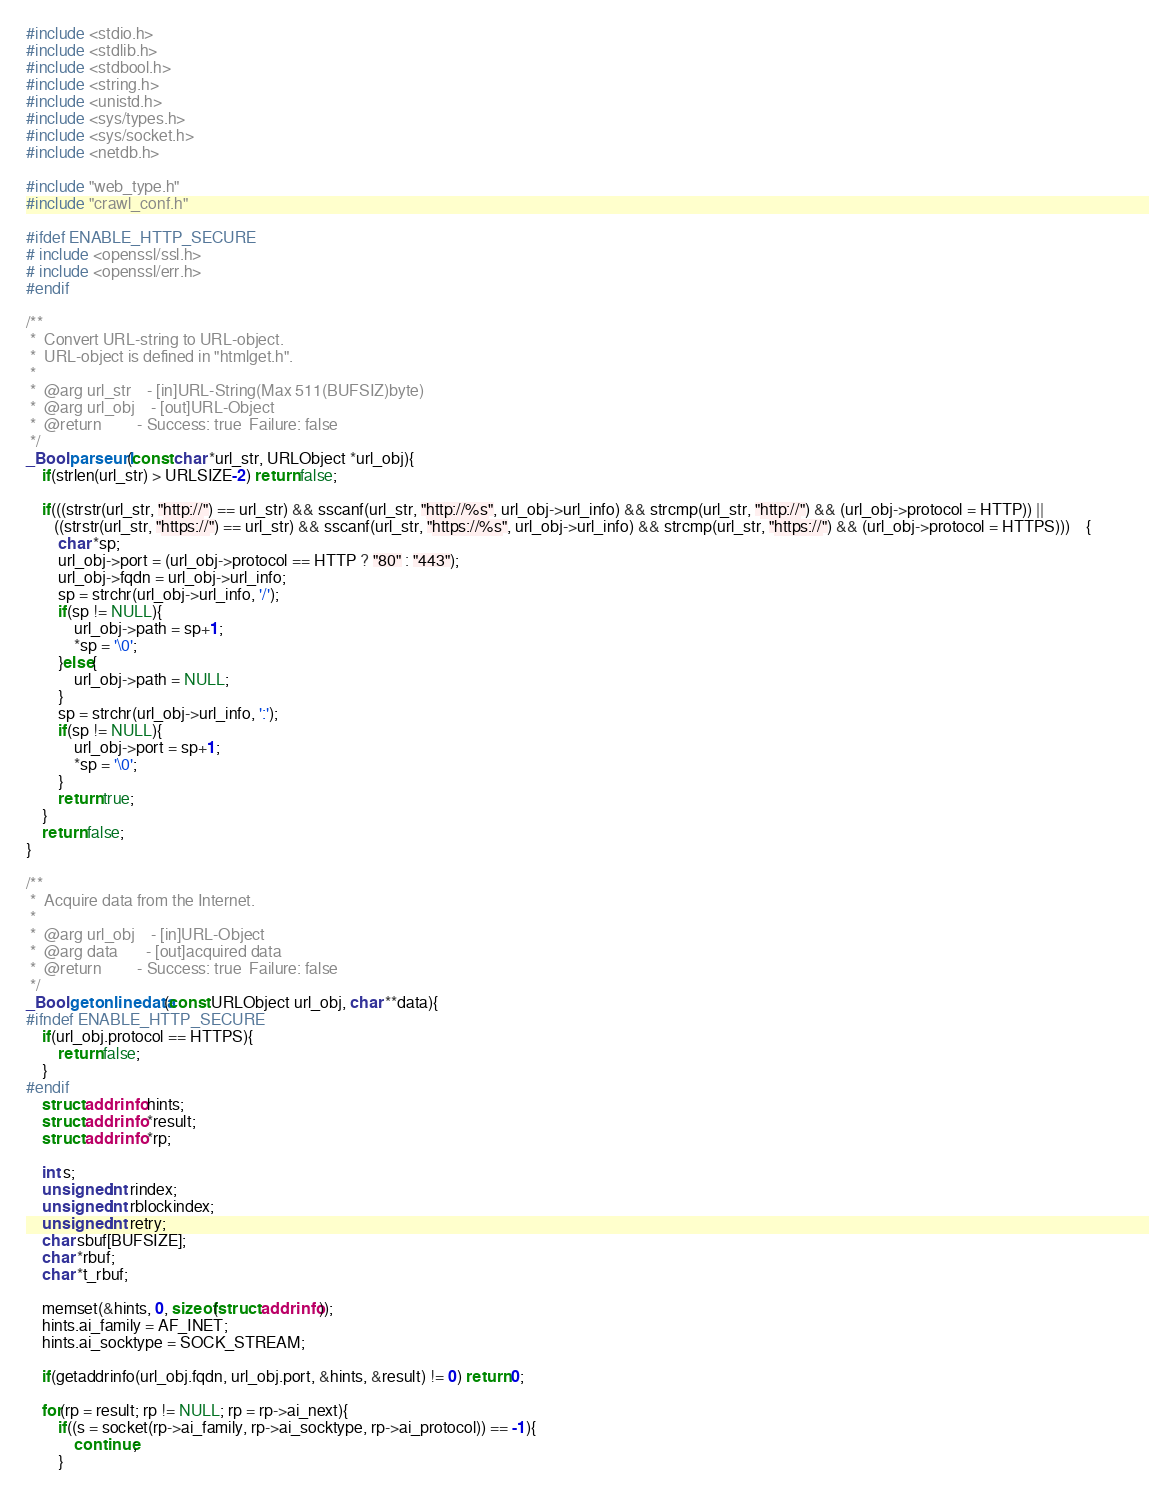Convert code to text. <code><loc_0><loc_0><loc_500><loc_500><_C_>#include <stdio.h>
#include <stdlib.h>
#include <stdbool.h>
#include <string.h>
#include <unistd.h>
#include <sys/types.h>
#include <sys/socket.h>
#include <netdb.h>

#include "web_type.h"
#include "crawl_conf.h"

#ifdef ENABLE_HTTP_SECURE
# include <openssl/ssl.h>
# include <openssl/err.h>
#endif

/**
 *	Convert URL-string to URL-object.
 *	URL-object is defined in "htmlget.h".
 *
 *	@arg url_str	- [in]URL-String(Max 511(BUFSIZ)byte)
 *	@arg url_obj	- [out]URL-Object
 *	@return			- Success: true  Failure: false
 */
_Bool parseurl(const char *url_str, URLObject *url_obj){
	if(strlen(url_str) > URLSIZE-2) return false;

	if(((strstr(url_str, "http://") == url_str) && sscanf(url_str, "http://%s", url_obj->url_info) && strcmp(url_str, "http://") && (url_obj->protocol = HTTP)) ||
	   ((strstr(url_str, "https://") == url_str) && sscanf(url_str, "https://%s", url_obj->url_info) && strcmp(url_str, "https://") && (url_obj->protocol = HTTPS)))	{		
		char *sp;
		url_obj->port = (url_obj->protocol == HTTP ? "80" : "443");
		url_obj->fqdn = url_obj->url_info;
		sp = strchr(url_obj->url_info, '/');
		if(sp != NULL){
			url_obj->path = sp+1;
			*sp = '\0';
		}else{
			url_obj->path = NULL;
		}
		sp = strchr(url_obj->url_info, ':');
		if(sp != NULL){
			url_obj->port = sp+1;
			*sp = '\0';
		}
		return true;
	}
	return false;
}

/**
 *	Acquire data from the Internet.
 *
 *	@arg url_obj	- [in]URL-Object
 *	@arg data		- [out]acquired data
 *	@return			- Success: true  Failure: false
 */
_Bool getonlinedata(const URLObject url_obj, char **data){
#ifndef ENABLE_HTTP_SECURE
	if(url_obj.protocol == HTTPS){
		return false;
	}
#endif
	struct addrinfo hints;
	struct addrinfo *result;
	struct addrinfo *rp;
	
	int s;
	unsigned int rindex;
	unsigned int rblockindex;
	unsigned int retry;
	char sbuf[BUFSIZE];
	char *rbuf;
	char *t_rbuf;
	
	memset(&hints, 0, sizeof(struct addrinfo));
	hints.ai_family = AF_INET;
	hints.ai_socktype = SOCK_STREAM;
	
	if(getaddrinfo(url_obj.fqdn, url_obj.port, &hints, &result) != 0) return 0;
	
	for(rp = result; rp != NULL; rp = rp->ai_next){
		if((s = socket(rp->ai_family, rp->ai_socktype, rp->ai_protocol)) == -1){
			continue;
		}</code> 